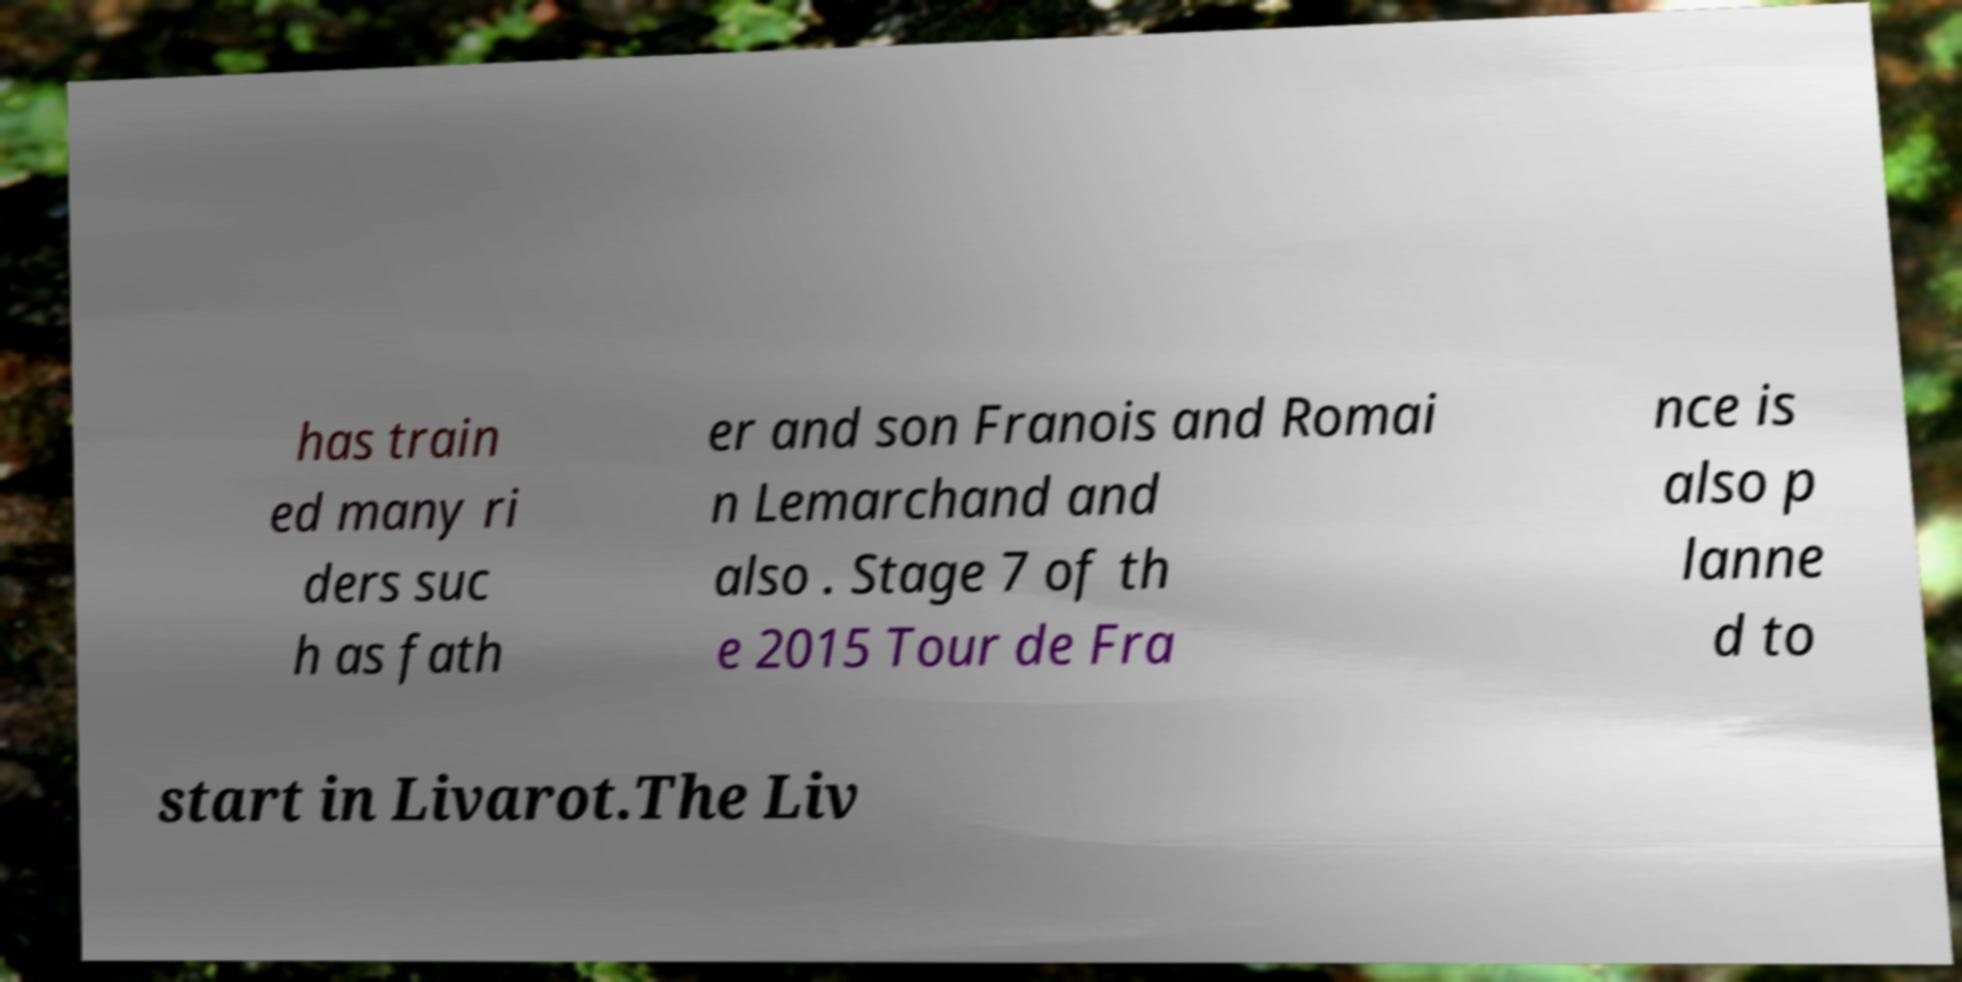Could you extract and type out the text from this image? has train ed many ri ders suc h as fath er and son Franois and Romai n Lemarchand and also . Stage 7 of th e 2015 Tour de Fra nce is also p lanne d to start in Livarot.The Liv 